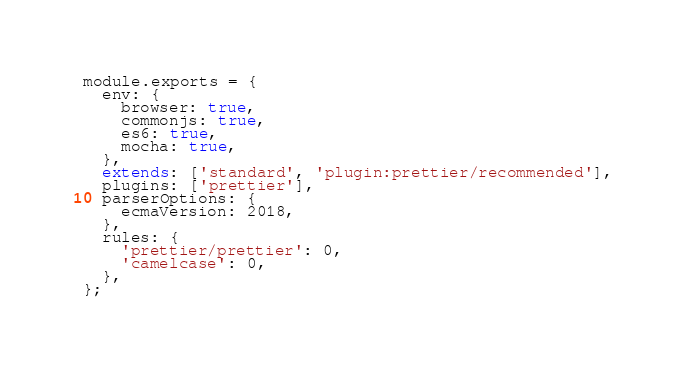<code> <loc_0><loc_0><loc_500><loc_500><_JavaScript_>module.exports = {
  env: {
    browser: true,
    commonjs: true,
    es6: true,
    mocha: true,
  },
  extends: ['standard', 'plugin:prettier/recommended'],
  plugins: ['prettier'],
  parserOptions: {
    ecmaVersion: 2018,
  },
  rules: {
    'prettier/prettier': 0,
    'camelcase': 0,
  },
};
</code> 